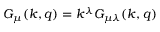Convert formula to latex. <formula><loc_0><loc_0><loc_500><loc_500>G _ { \mu } ( k , q ) = k ^ { \lambda } G _ { \mu \lambda } ( k , q )</formula> 